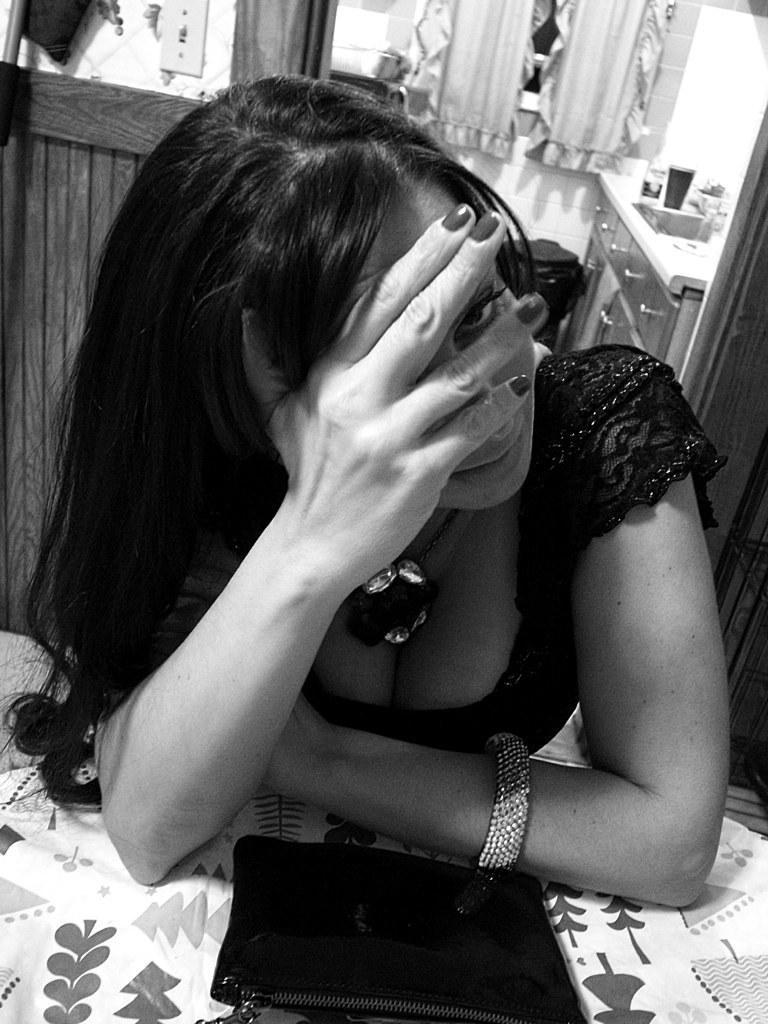Who is the main subject in the foreground of the image? There is a lady in the foreground of the image. What is the lady holding in her hand? The lady is holding a clutch. What can be seen in the background of the image? There are cupboards, curtains, a glass object, and other objects in the background of the image. What type of activity is the bird performing in the image? There is no bird present in the image, so no such activity can be observed. 